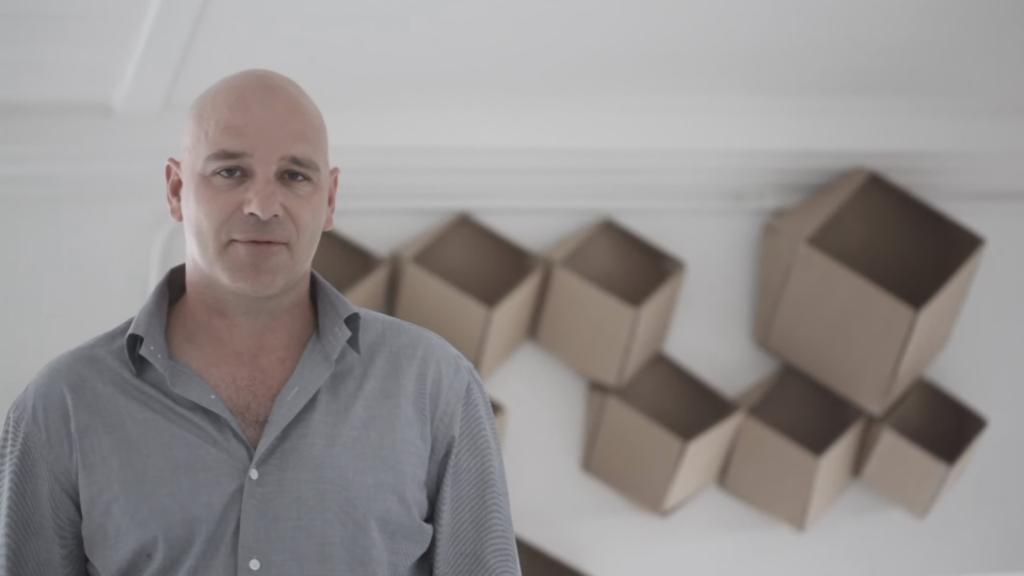What is the main subject of the image? There is a person standing in the image. What is the person wearing? The person is wearing an ash-colored dress. Can you describe the background of the image? The background on the back side of the image is white and brown in color. How many girls are playing in the air in the image? There are no girls or any indication of playing in the air in the image; it features a person standing in an ash-colored dress with a white and brown background. 